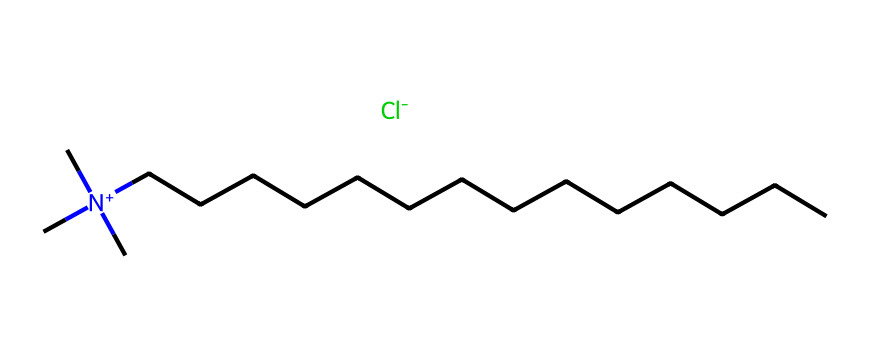What is the central atom in this compound? The central atom in this compound is nitrogen, indicated by the [N+] notation in the SMILES representation, which shows it is positively charged and bonded to three carbon groups and a long alkyl chain.
Answer: nitrogen How many carbon atoms are present in the structure? The structure shows three carbon atoms attached to the nitrogen and a 14-carbon long alkyl chain (as indicated by the CCCCCCCCCCCCCC in the SMILES). Therefore, there are a total of 17 carbon atoms.
Answer: 17 How many chlorine atoms are in this compound? The SMILES notation includes only one chlorine atom, denoted by the [Cl-] at the end of the representation, indicating that there is a single chloride anion present.
Answer: 1 What type of chemical is represented by this structure? This structure represents a quaternary ammonium compound, which is evident from the positively charged nitrogen that is bonded to three organic groups and one long-chain alkyl.
Answer: quaternary ammonium What is the charge of the nitrogen atom in this compound? The nitrogen atom is indicated as positively charged in the SMILES notation by the [N+], meaning it carries a positive charge due to its quaternary nature with four substituents.
Answer: positive What property of this compound makes it useful as a disinfectant? The long hydrophobic carbon chain (alkyl group) combined with the cationic nitrogen allows this compound to effectively disrupt microbial cell membranes, which is a key property that makes quaternary ammonium compounds effective disinfectants.
Answer: disrupts microbial membranes How does the structure relate to its solubility in water? The presence of the positive nitrogen and the polar nature of the quaternary ammonium compounds enhance solubility in water due to electrostatic interactions with water molecules, while the long non-polar alkyl chain provides hydrophobic characteristics.
Answer: polar nitrogen enhances solubility 